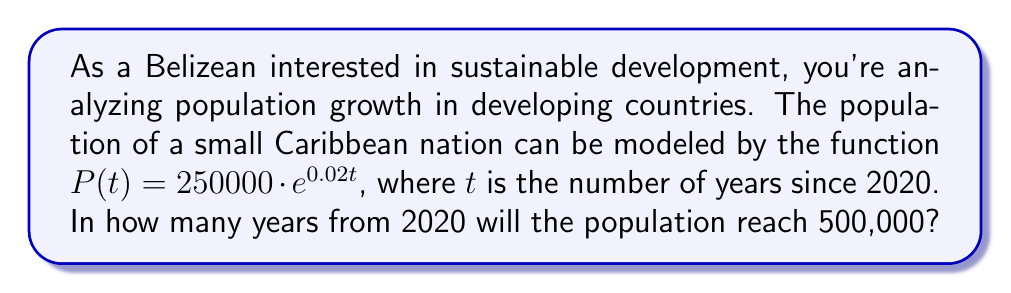What is the answer to this math problem? Let's approach this step-by-step:

1) We're given the population function: $P(t) = 250000 \cdot e^{0.02t}$

2) We want to find $t$ when $P(t) = 500000$. So, let's set up the equation:

   $500000 = 250000 \cdot e^{0.02t}$

3) Divide both sides by 250000:

   $2 = e^{0.02t}$

4) Now, we need to solve for $t$. We can do this by taking the natural logarithm of both sides:

   $\ln(2) = \ln(e^{0.02t})$

5) The right side simplifies due to the properties of logarithms:

   $\ln(2) = 0.02t$

6) Now we can solve for $t$:

   $t = \frac{\ln(2)}{0.02}$

7) Calculate this value:

   $t = \frac{0.693147...}{0.02} \approx 34.66$ years

8) Since we're asked for the number of years, we round up to the next whole year.
Answer: 35 years 